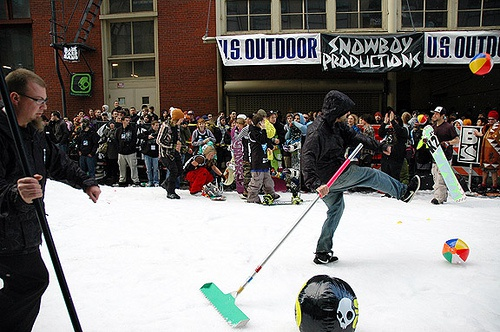Describe the objects in this image and their specific colors. I can see people in black, maroon, and gray tones, people in black, gray, purple, and white tones, sports ball in black, gray, darkgray, and lightgray tones, people in black, gray, darkgray, and lightgray tones, and people in black, gray, brown, and darkgray tones in this image. 